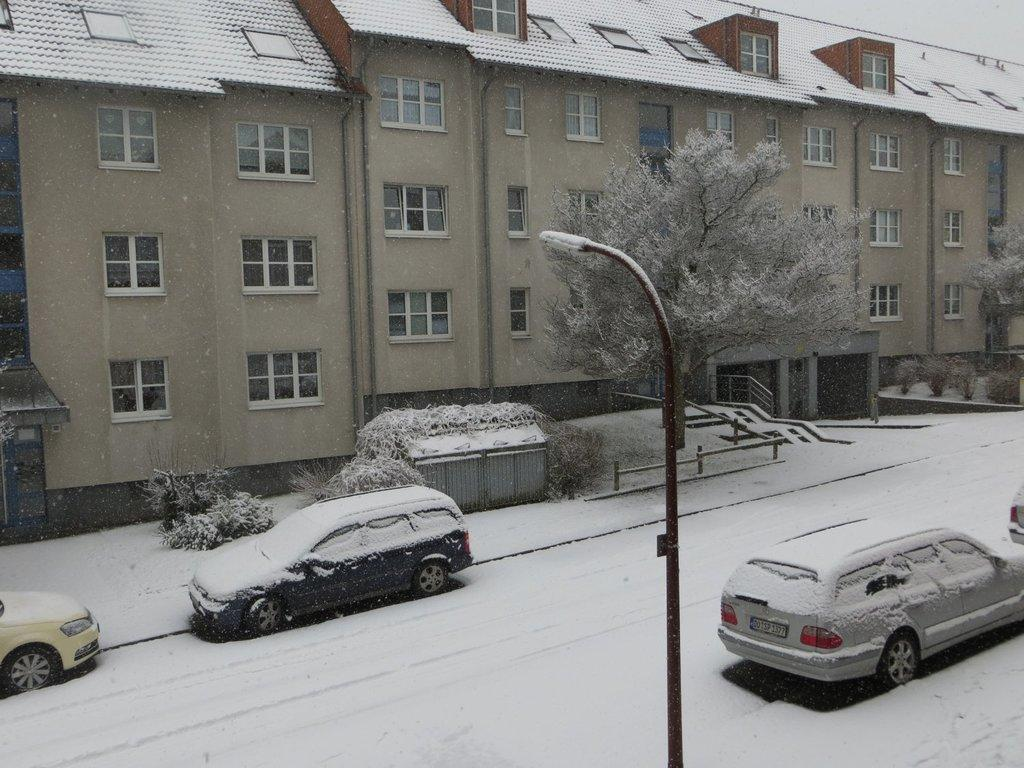What type of structure is present in the image? There is a building in the image. Can you describe the building's appearance? The building has multiple windows. What other elements can be seen in the image? There are plants, trees, vehicles, a pole, and a street light in the image. What is the weather like in the image? Snow is visible in the image. What type of produce is being served at the feast in the image? There is no feast or produce present in the image. Can you describe the arch that is part of the building's design in the image? There is no arch mentioned or visible in the image. 